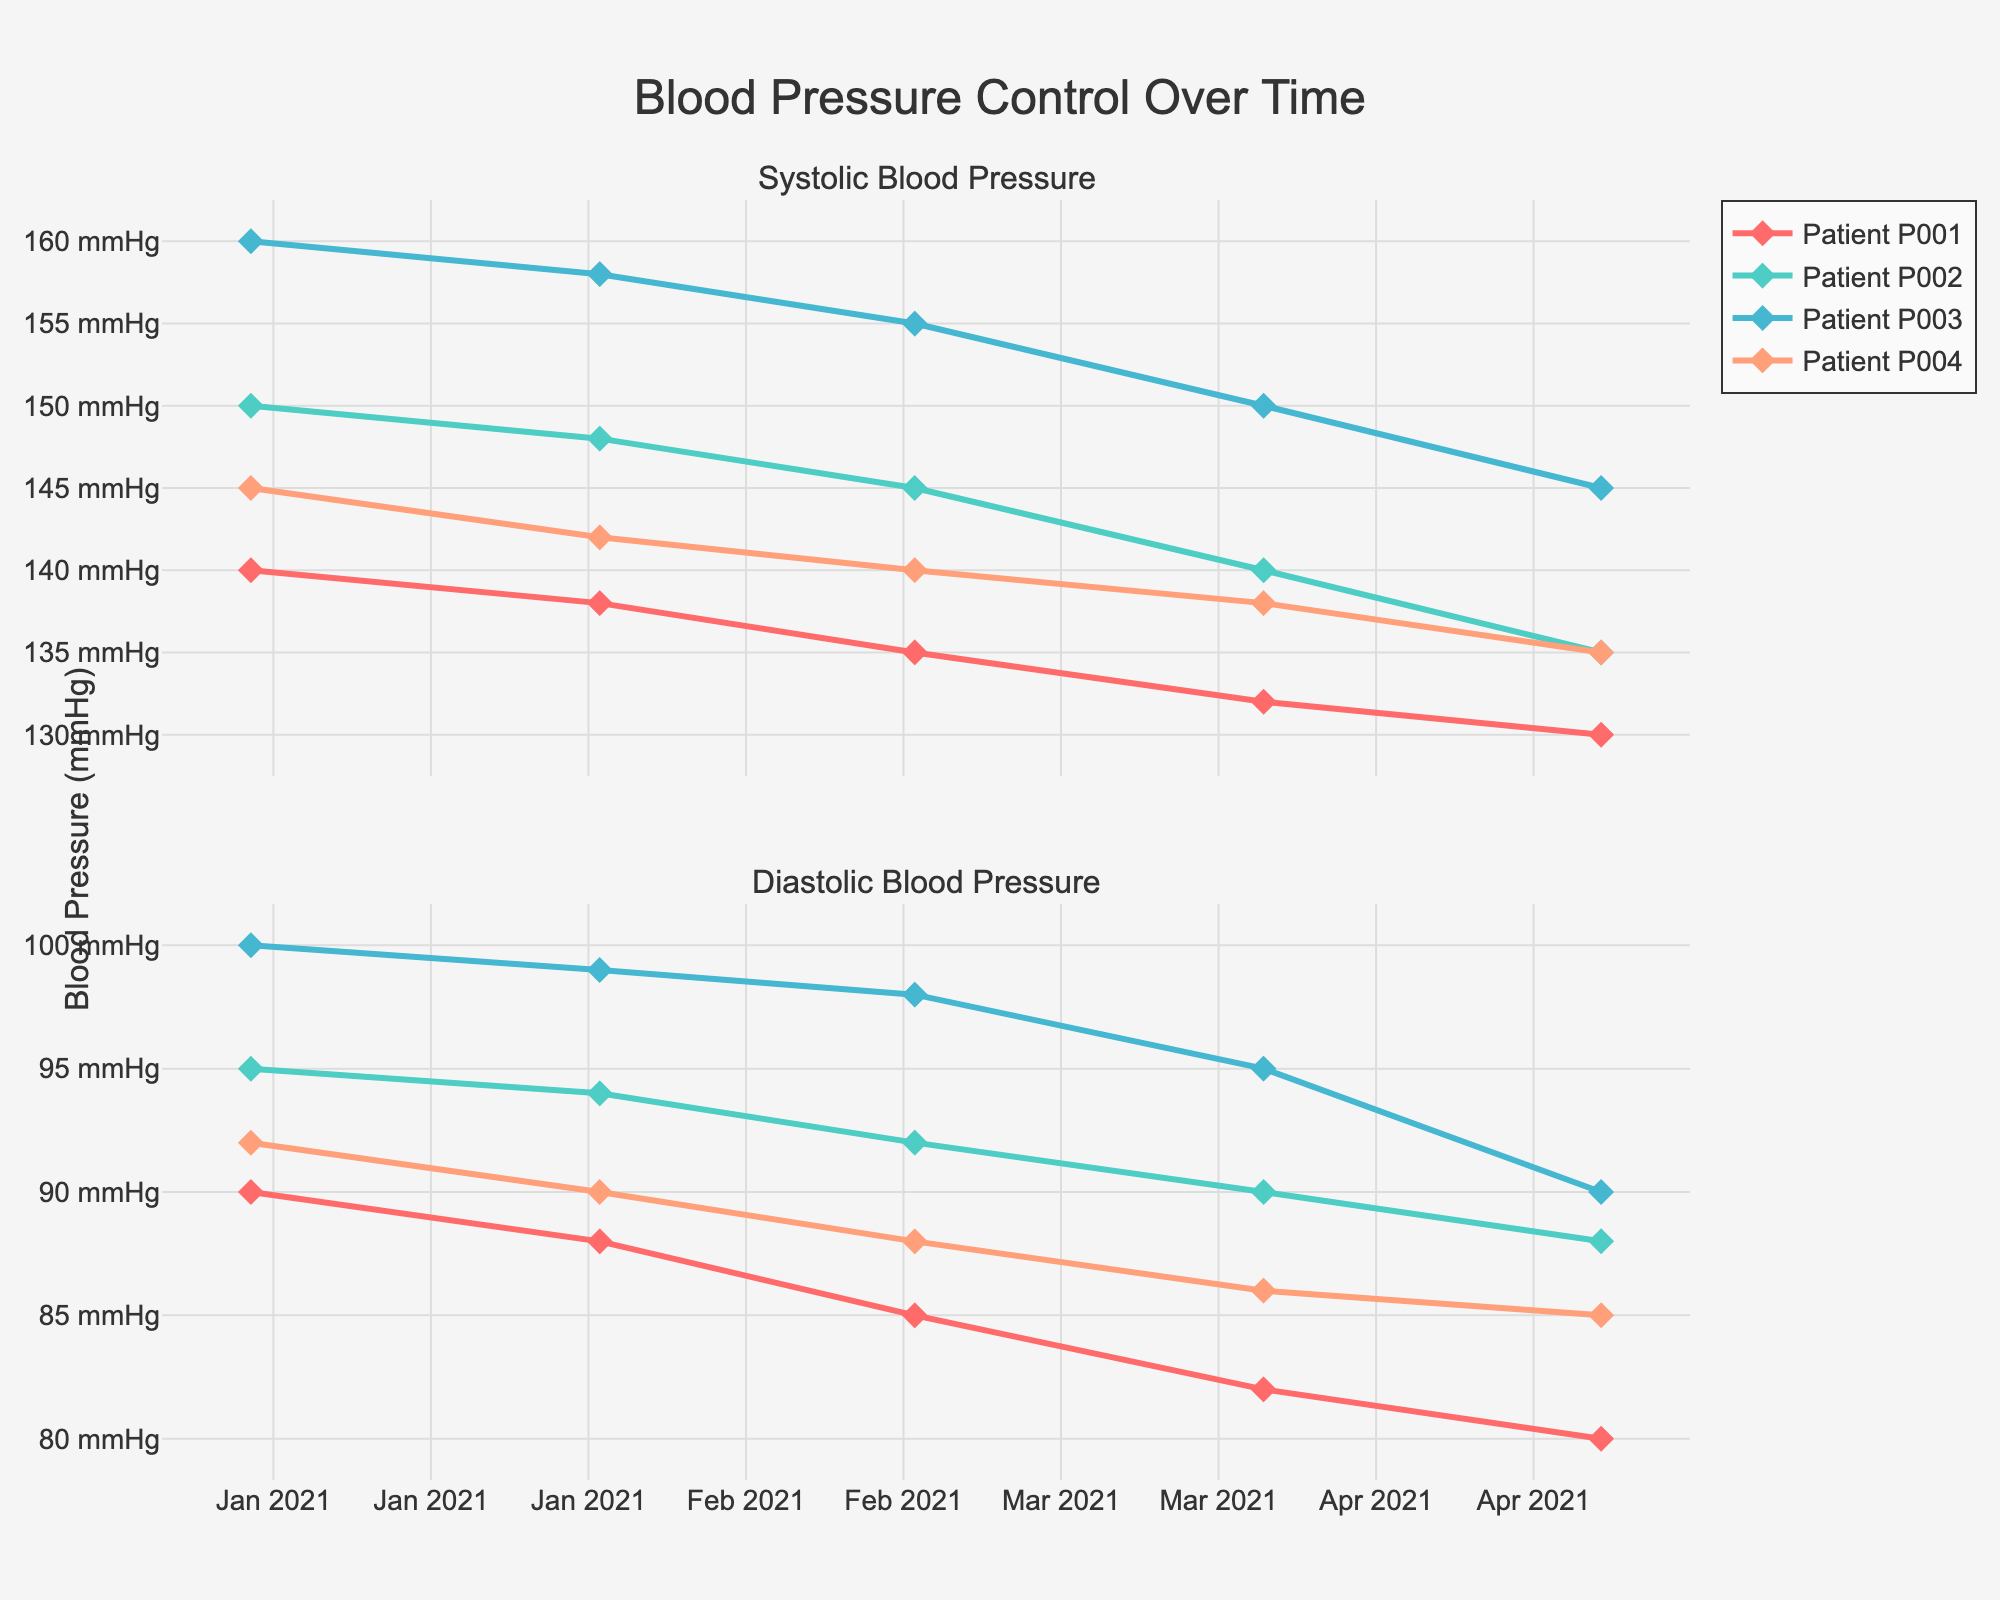What is the title of the figure? The title is displayed at the top center of the figure. It reads "Blood Pressure Control Over Time".
Answer: Blood Pressure Control Over Time How many patients are represented in the figure? The figure uses different colors and markers for each patient, showing that there are four unique patients. Each patient is labeled as Patient P001, P002, P003, and P004.
Answer: 4 Which patient has the highest initial systolic blood pressure? Looking at the first data point (January 2021) on the systolic blood pressure subplot, Patient P003 starts with the highest value.
Answer: P003 What trend can be observed for Patient P002's blood pressure over the period? Both the systolic and diastolic blood pressure of Patient P002 show a consistent downward trend from January 2021 to May 2021.
Answer: Downward trend Between January and May 2021, which patient shows the most significant decrease in diastolic blood pressure? By comparing the starting and ending diastolic pressures on the diastolic plot, Patient P001 drops from 90 to 80, Patient P002 from 95 to 88, Patient P003 from 100 to 90, and Patient P004 from 92 to 85. After calculation, P003 shows a decrease of 10 mmHg, which is the largest decrease.
Answer: P003 What is the average systolic blood pressure for Patient P004 over the given period? Add the systolic blood pressure values for Patient P004 (145+142+140+138+135) and divide by the number of months (5), which results in the average. (145 + 142 + 140 + 138 + 135) / 5 = 140
Answer: 140 Who has the lowest blood pressure at the end of the period? Looking at the May 2021 data across both systolic and diastolic plots, the lowest blood pressure is shown by Patient P001, which shows 130/80.
Answer: P001 How does the blood pressure control rate differ between Patient P001 and Patient P002? Patient P001 shows a steady decrease in both systolic and diastolic blood pressure, indicating better control compared to Patient P002, whose values decrease more gradually and start from a higher level.
Answer: Better control for P001 On average, how many weeks does it take for Patient P003 to show a 5 mmHg reduction in systolic blood pressure? Over five months, Patient P003’s systolic pressure reduces from 160 to 145, giving a reduction of 15 mmHg, which occurs over 20 weeks. Thus, the average time to reduce 5 mmHg is calculated by (5/15) * 20 = roughly 6.67 weeks.
Answer: 6.67 weeks 